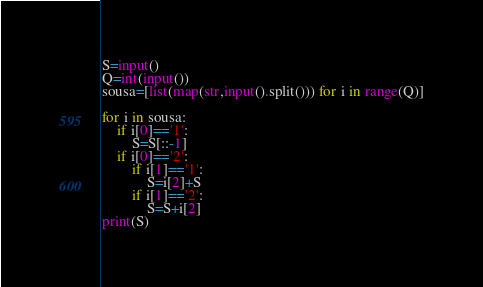Convert code to text. <code><loc_0><loc_0><loc_500><loc_500><_Python_>S=input()
Q=int(input())
sousa=[list(map(str,input().split())) for i in range(Q)]

for i in sousa:
    if i[0]=='1':
        S=S[::-1]
    if i[0]=='2':
        if i[1]=='1':
            S=i[2]+S
        if i[1]=='2':
            S=S+i[2]
print(S)</code> 